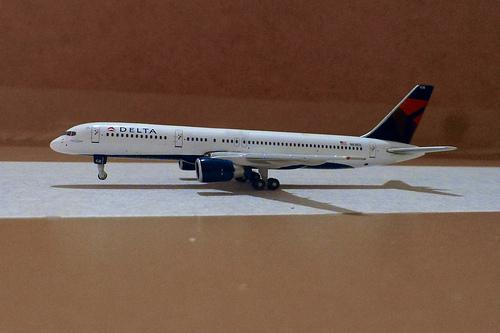Question: how was this picture lit?
Choices:
A. Strobe lights.
B. Gas light.
C. Natural light.
D. Street lights.
Answer with the letter. Answer: C Question: what airline is on the plane?
Choices:
A. Delta.
B. Southwest.
C. Trans american.
D. Virgin.
Answer with the letter. Answer: A Question: what is on the ground below the plane?
Choices:
A. Shadow.
B. Truck.
C. Suit cases.
D. Mechanic.
Answer with the letter. Answer: A Question: where was this picture taken?
Choices:
A. On the train.
B. On the plane.
C. On the jet.
D. On a runway.
Answer with the letter. Answer: D 